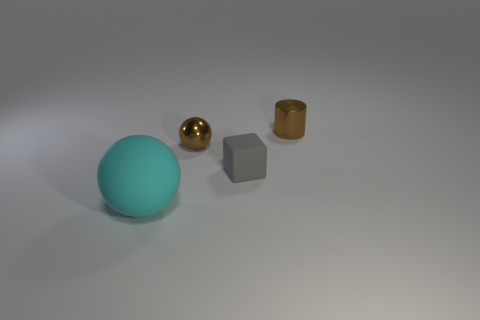Are there any other things that have the same size as the matte sphere?
Offer a very short reply. No. There is a tiny object that is the same color as the small metal cylinder; what shape is it?
Offer a terse response. Sphere. Are any small rubber cubes visible?
Ensure brevity in your answer.  Yes. Is the number of large brown rubber cubes less than the number of tiny brown objects?
Offer a terse response. Yes. Are there any gray rubber objects that have the same size as the matte sphere?
Keep it short and to the point. No. There is a big matte object; is its shape the same as the shiny thing that is in front of the small brown shiny cylinder?
Provide a short and direct response. Yes. How many spheres are green objects or matte things?
Your answer should be compact. 1. The tiny cylinder is what color?
Offer a terse response. Brown. Is the number of red metal spheres greater than the number of tiny brown shiny balls?
Ensure brevity in your answer.  No. How many objects are either rubber things that are on the right side of the cyan matte object or yellow metallic balls?
Provide a short and direct response. 1. 